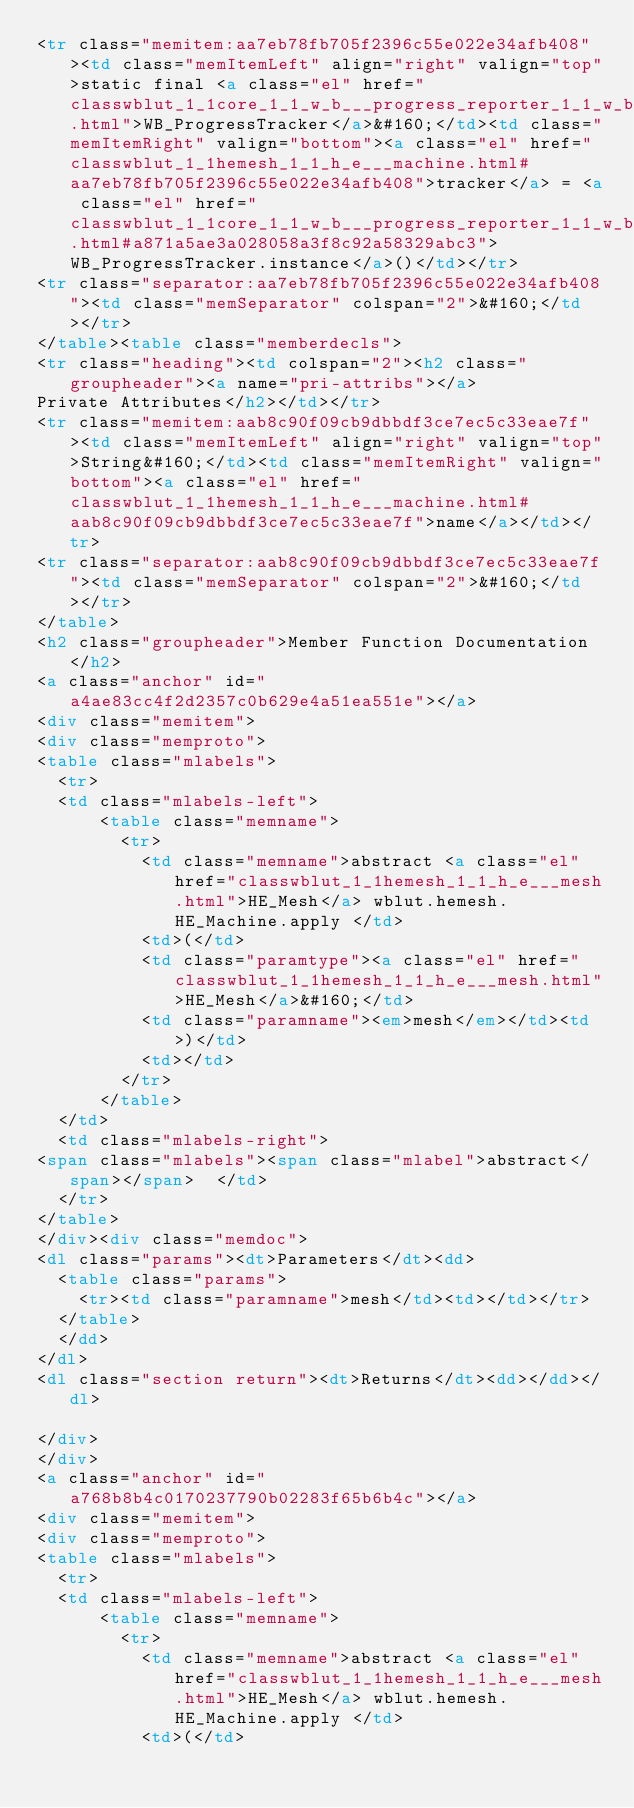Convert code to text. <code><loc_0><loc_0><loc_500><loc_500><_HTML_><tr class="memitem:aa7eb78fb705f2396c55e022e34afb408"><td class="memItemLeft" align="right" valign="top">static final <a class="el" href="classwblut_1_1core_1_1_w_b___progress_reporter_1_1_w_b___progress_tracker.html">WB_ProgressTracker</a>&#160;</td><td class="memItemRight" valign="bottom"><a class="el" href="classwblut_1_1hemesh_1_1_h_e___machine.html#aa7eb78fb705f2396c55e022e34afb408">tracker</a> = <a class="el" href="classwblut_1_1core_1_1_w_b___progress_reporter_1_1_w_b___progress_tracker.html#a871a5ae3a028058a3f8c92a58329abc3">WB_ProgressTracker.instance</a>()</td></tr>
<tr class="separator:aa7eb78fb705f2396c55e022e34afb408"><td class="memSeparator" colspan="2">&#160;</td></tr>
</table><table class="memberdecls">
<tr class="heading"><td colspan="2"><h2 class="groupheader"><a name="pri-attribs"></a>
Private Attributes</h2></td></tr>
<tr class="memitem:aab8c90f09cb9dbbdf3ce7ec5c33eae7f"><td class="memItemLeft" align="right" valign="top">String&#160;</td><td class="memItemRight" valign="bottom"><a class="el" href="classwblut_1_1hemesh_1_1_h_e___machine.html#aab8c90f09cb9dbbdf3ce7ec5c33eae7f">name</a></td></tr>
<tr class="separator:aab8c90f09cb9dbbdf3ce7ec5c33eae7f"><td class="memSeparator" colspan="2">&#160;</td></tr>
</table>
<h2 class="groupheader">Member Function Documentation</h2>
<a class="anchor" id="a4ae83cc4f2d2357c0b629e4a51ea551e"></a>
<div class="memitem">
<div class="memproto">
<table class="mlabels">
  <tr>
  <td class="mlabels-left">
      <table class="memname">
        <tr>
          <td class="memname">abstract <a class="el" href="classwblut_1_1hemesh_1_1_h_e___mesh.html">HE_Mesh</a> wblut.hemesh.HE_Machine.apply </td>
          <td>(</td>
          <td class="paramtype"><a class="el" href="classwblut_1_1hemesh_1_1_h_e___mesh.html">HE_Mesh</a>&#160;</td>
          <td class="paramname"><em>mesh</em></td><td>)</td>
          <td></td>
        </tr>
      </table>
  </td>
  <td class="mlabels-right">
<span class="mlabels"><span class="mlabel">abstract</span></span>  </td>
  </tr>
</table>
</div><div class="memdoc">
<dl class="params"><dt>Parameters</dt><dd>
  <table class="params">
    <tr><td class="paramname">mesh</td><td></td></tr>
  </table>
  </dd>
</dl>
<dl class="section return"><dt>Returns</dt><dd></dd></dl>

</div>
</div>
<a class="anchor" id="a768b8b4c0170237790b02283f65b6b4c"></a>
<div class="memitem">
<div class="memproto">
<table class="mlabels">
  <tr>
  <td class="mlabels-left">
      <table class="memname">
        <tr>
          <td class="memname">abstract <a class="el" href="classwblut_1_1hemesh_1_1_h_e___mesh.html">HE_Mesh</a> wblut.hemesh.HE_Machine.apply </td>
          <td>(</td></code> 